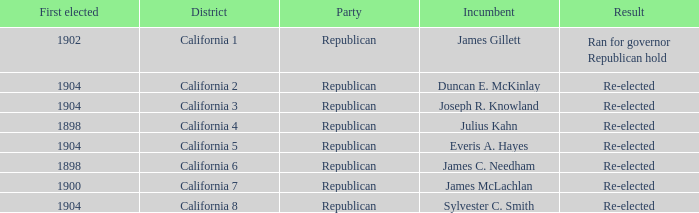Which Incumbent has a District of California 8? Sylvester C. Smith. 